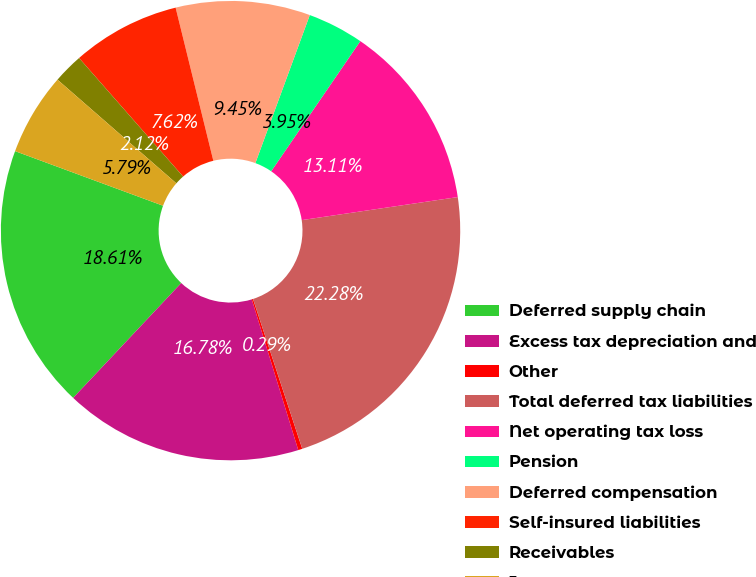Convert chart. <chart><loc_0><loc_0><loc_500><loc_500><pie_chart><fcel>Deferred supply chain<fcel>Excess tax depreciation and<fcel>Other<fcel>Total deferred tax liabilities<fcel>Net operating tax loss<fcel>Pension<fcel>Deferred compensation<fcel>Self-insured liabilities<fcel>Receivables<fcel>Inventory<nl><fcel>18.61%<fcel>16.78%<fcel>0.29%<fcel>22.28%<fcel>13.11%<fcel>3.95%<fcel>9.45%<fcel>7.62%<fcel>2.12%<fcel>5.79%<nl></chart> 